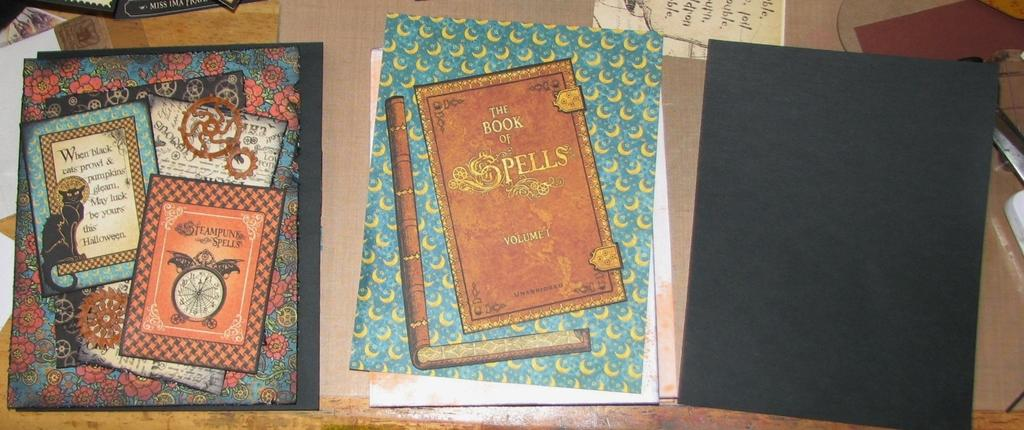<image>
Present a compact description of the photo's key features. A book with the text, A book of Spells, lays on a desk. 